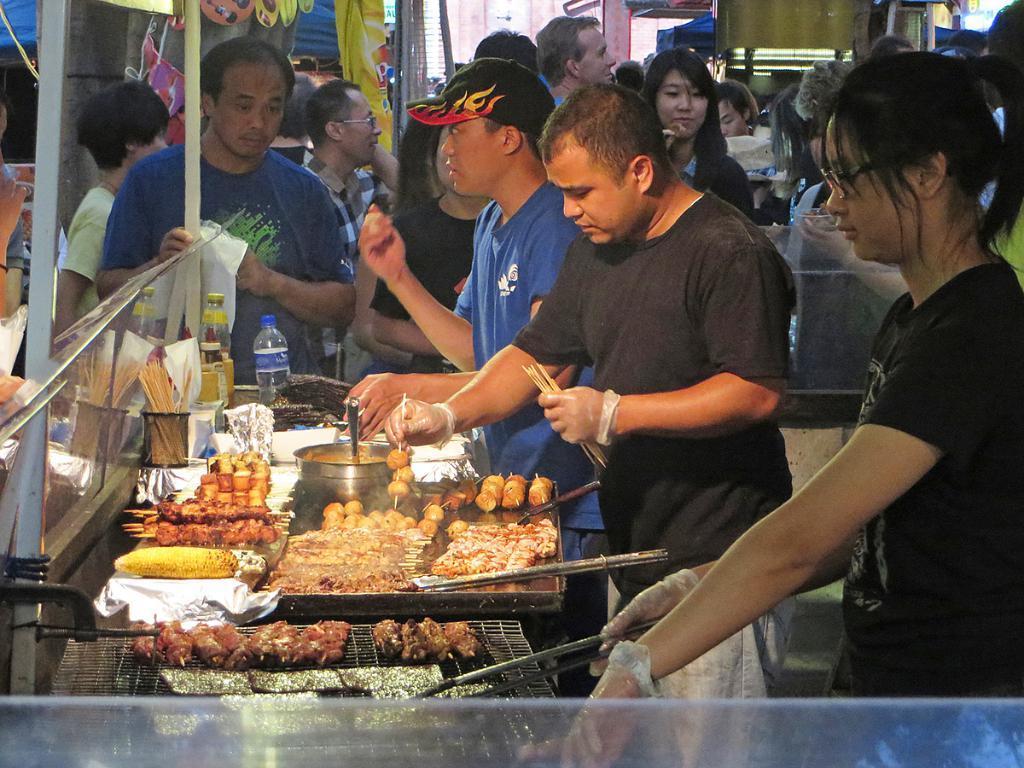Please provide a concise description of this image. In this image I can see a food visible on the table and I can see there is a person holding sticks and I can see there are few persons visible 